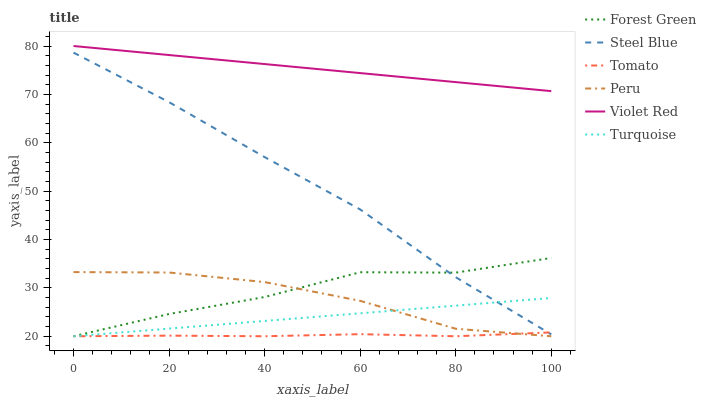Does Tomato have the minimum area under the curve?
Answer yes or no. Yes. Does Violet Red have the maximum area under the curve?
Answer yes or no. Yes. Does Turquoise have the minimum area under the curve?
Answer yes or no. No. Does Turquoise have the maximum area under the curve?
Answer yes or no. No. Is Turquoise the smoothest?
Answer yes or no. Yes. Is Forest Green the roughest?
Answer yes or no. Yes. Is Violet Red the smoothest?
Answer yes or no. No. Is Violet Red the roughest?
Answer yes or no. No. Does Tomato have the lowest value?
Answer yes or no. Yes. Does Violet Red have the lowest value?
Answer yes or no. No. Does Violet Red have the highest value?
Answer yes or no. Yes. Does Turquoise have the highest value?
Answer yes or no. No. Is Peru less than Steel Blue?
Answer yes or no. Yes. Is Violet Red greater than Tomato?
Answer yes or no. Yes. Does Peru intersect Tomato?
Answer yes or no. Yes. Is Peru less than Tomato?
Answer yes or no. No. Is Peru greater than Tomato?
Answer yes or no. No. Does Peru intersect Steel Blue?
Answer yes or no. No. 